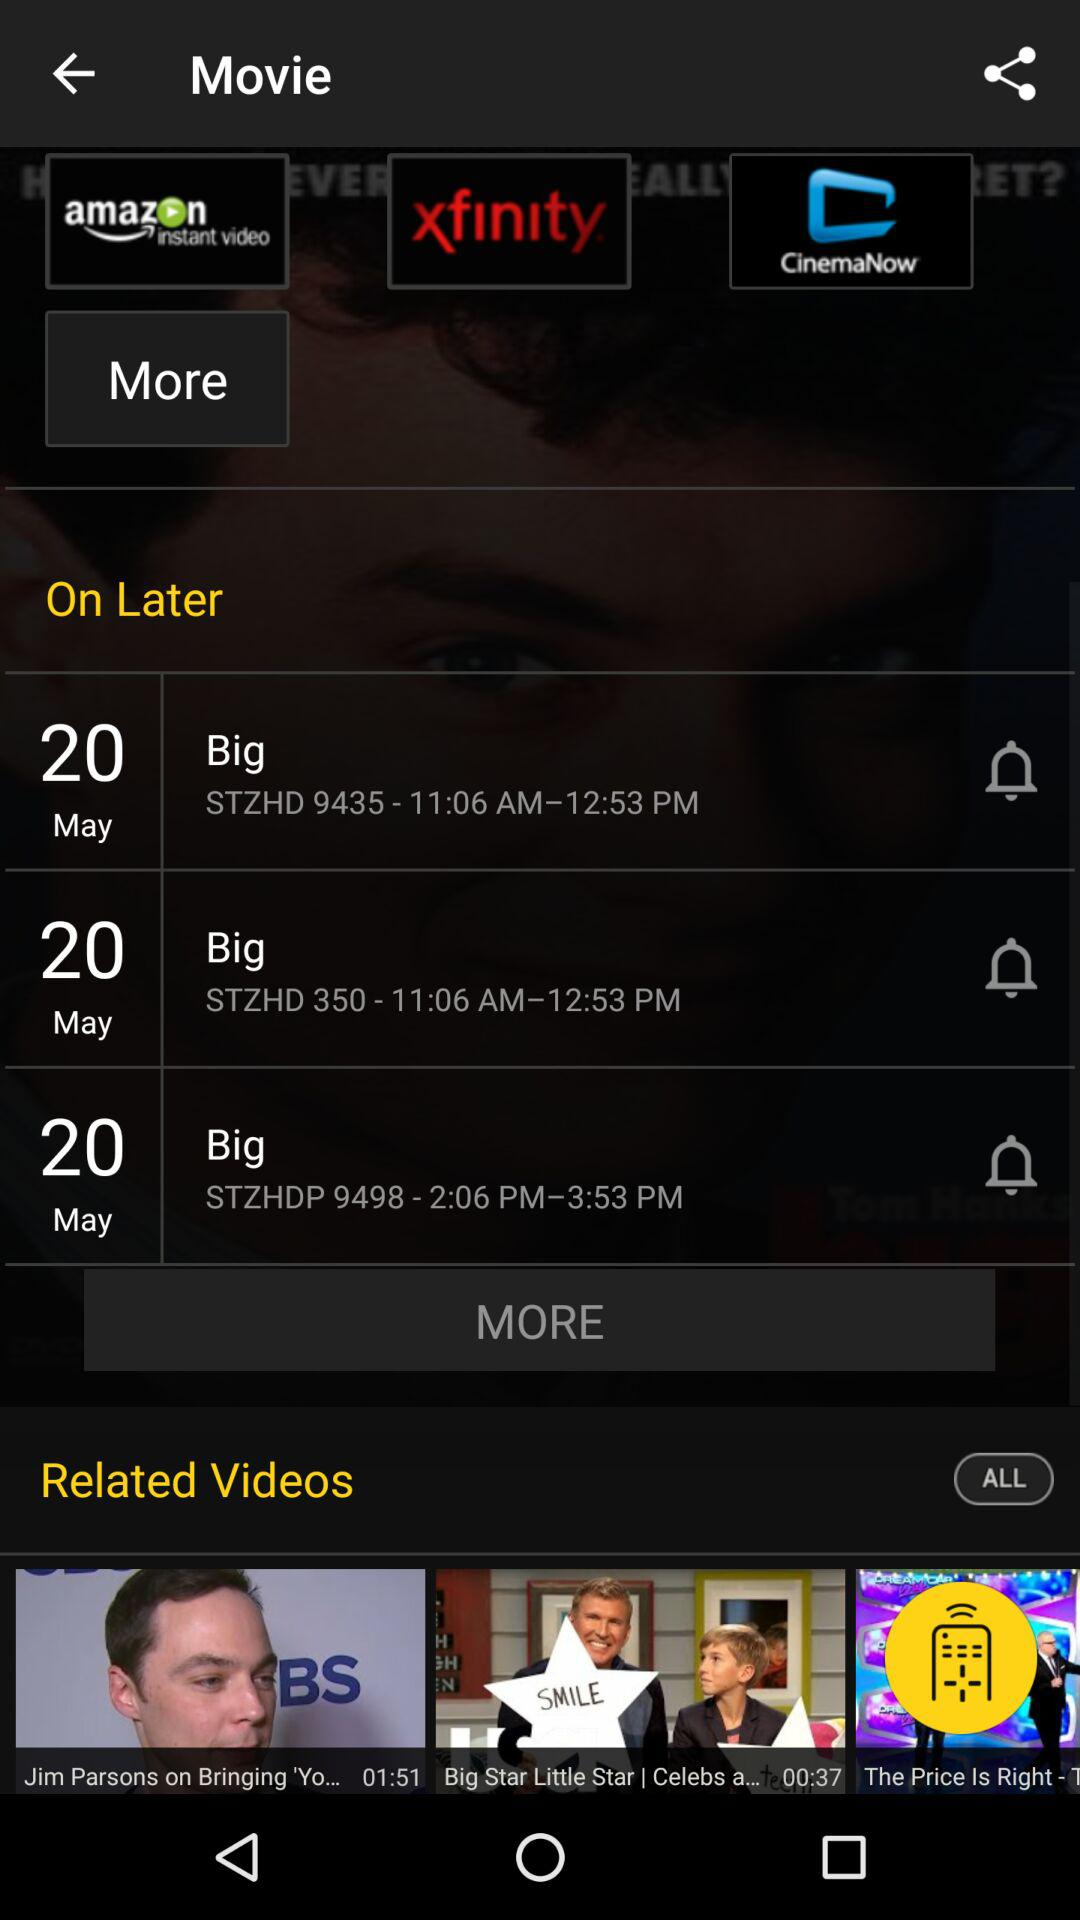Which date is mentioned for "STZHDP 9498 - 2:06 PM—3:53 PM"? The mentioned date is May 20. 